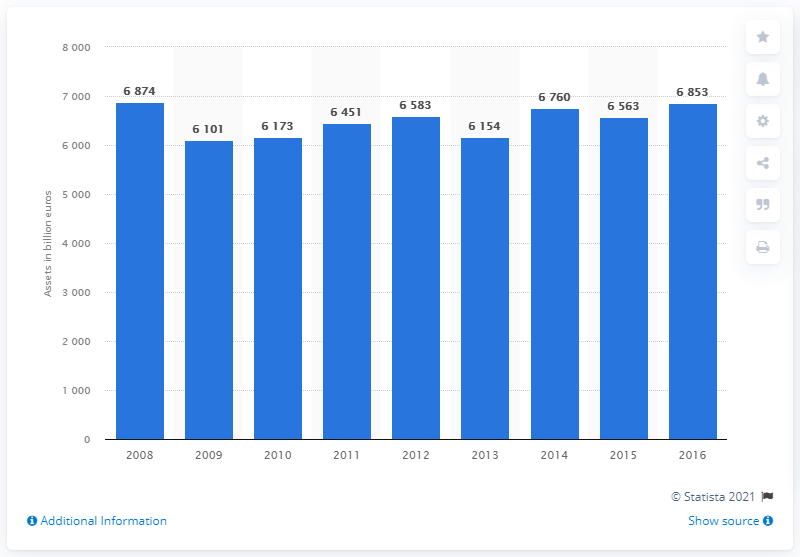Outline some significant characteristics in this image. In 2016, the value of the assets of French domestic banks was 6,853. 